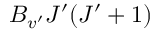<formula> <loc_0><loc_0><loc_500><loc_500>B _ { v ^ { \prime } } J ^ { \prime } ( J ^ { \prime } + 1 )</formula> 